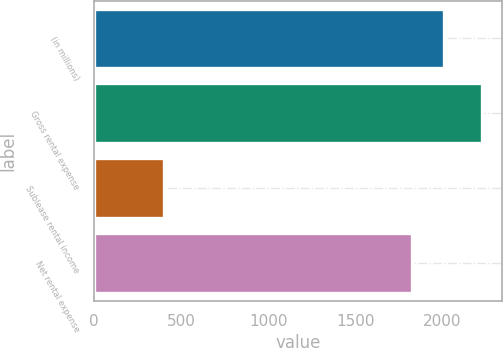Convert chart. <chart><loc_0><loc_0><loc_500><loc_500><bar_chart><fcel>(in millions)<fcel>Gross rental expense<fcel>Sublease rental income<fcel>Net rental expense<nl><fcel>2011<fcel>2228<fcel>403<fcel>1825<nl></chart> 